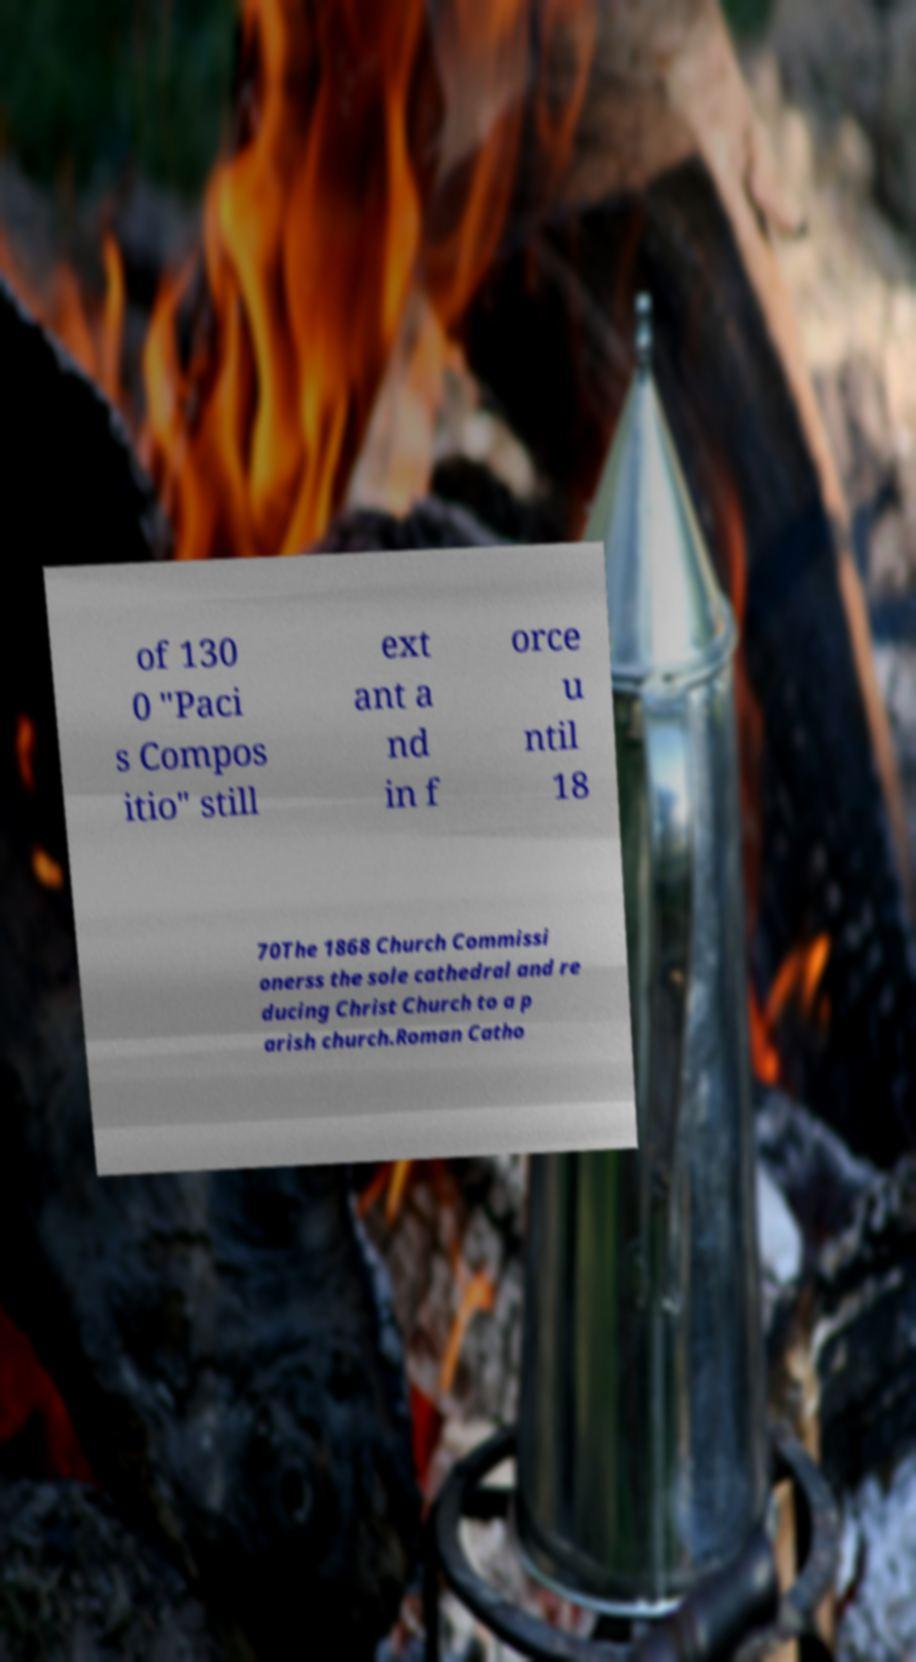Could you assist in decoding the text presented in this image and type it out clearly? of 130 0 "Paci s Compos itio" still ext ant a nd in f orce u ntil 18 70The 1868 Church Commissi onerss the sole cathedral and re ducing Christ Church to a p arish church.Roman Catho 